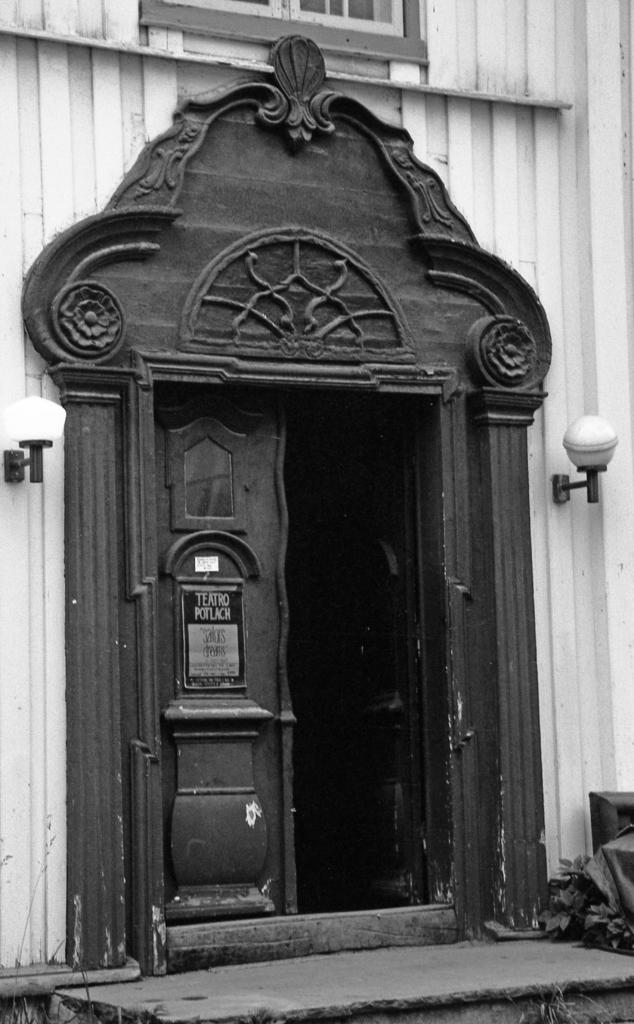What is the color scheme of the image? The image is black and white. What type of structure is present in the image? There is a building in the image. What architectural features can be seen on the building? The building has windows and doors. What else is visible in the image besides the building? There are lights, a plant, and a path visible in the image. How many chairs are placed around the plant in the image? There are no chairs present in the image; it only features a building, lights, a plant, and a path. 